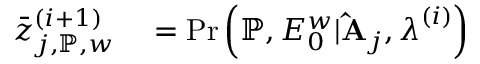<formula> <loc_0><loc_0><loc_500><loc_500>\begin{array} { r l } { \bar { z } _ { j , \mathbb { P } , w } ^ { ( i + 1 ) } } & = P r \left ( \mathbb { P } , E _ { 0 } ^ { w } | \hat { A } _ { j } , \lambda ^ { ( i ) } \right ) } \end{array}</formula> 